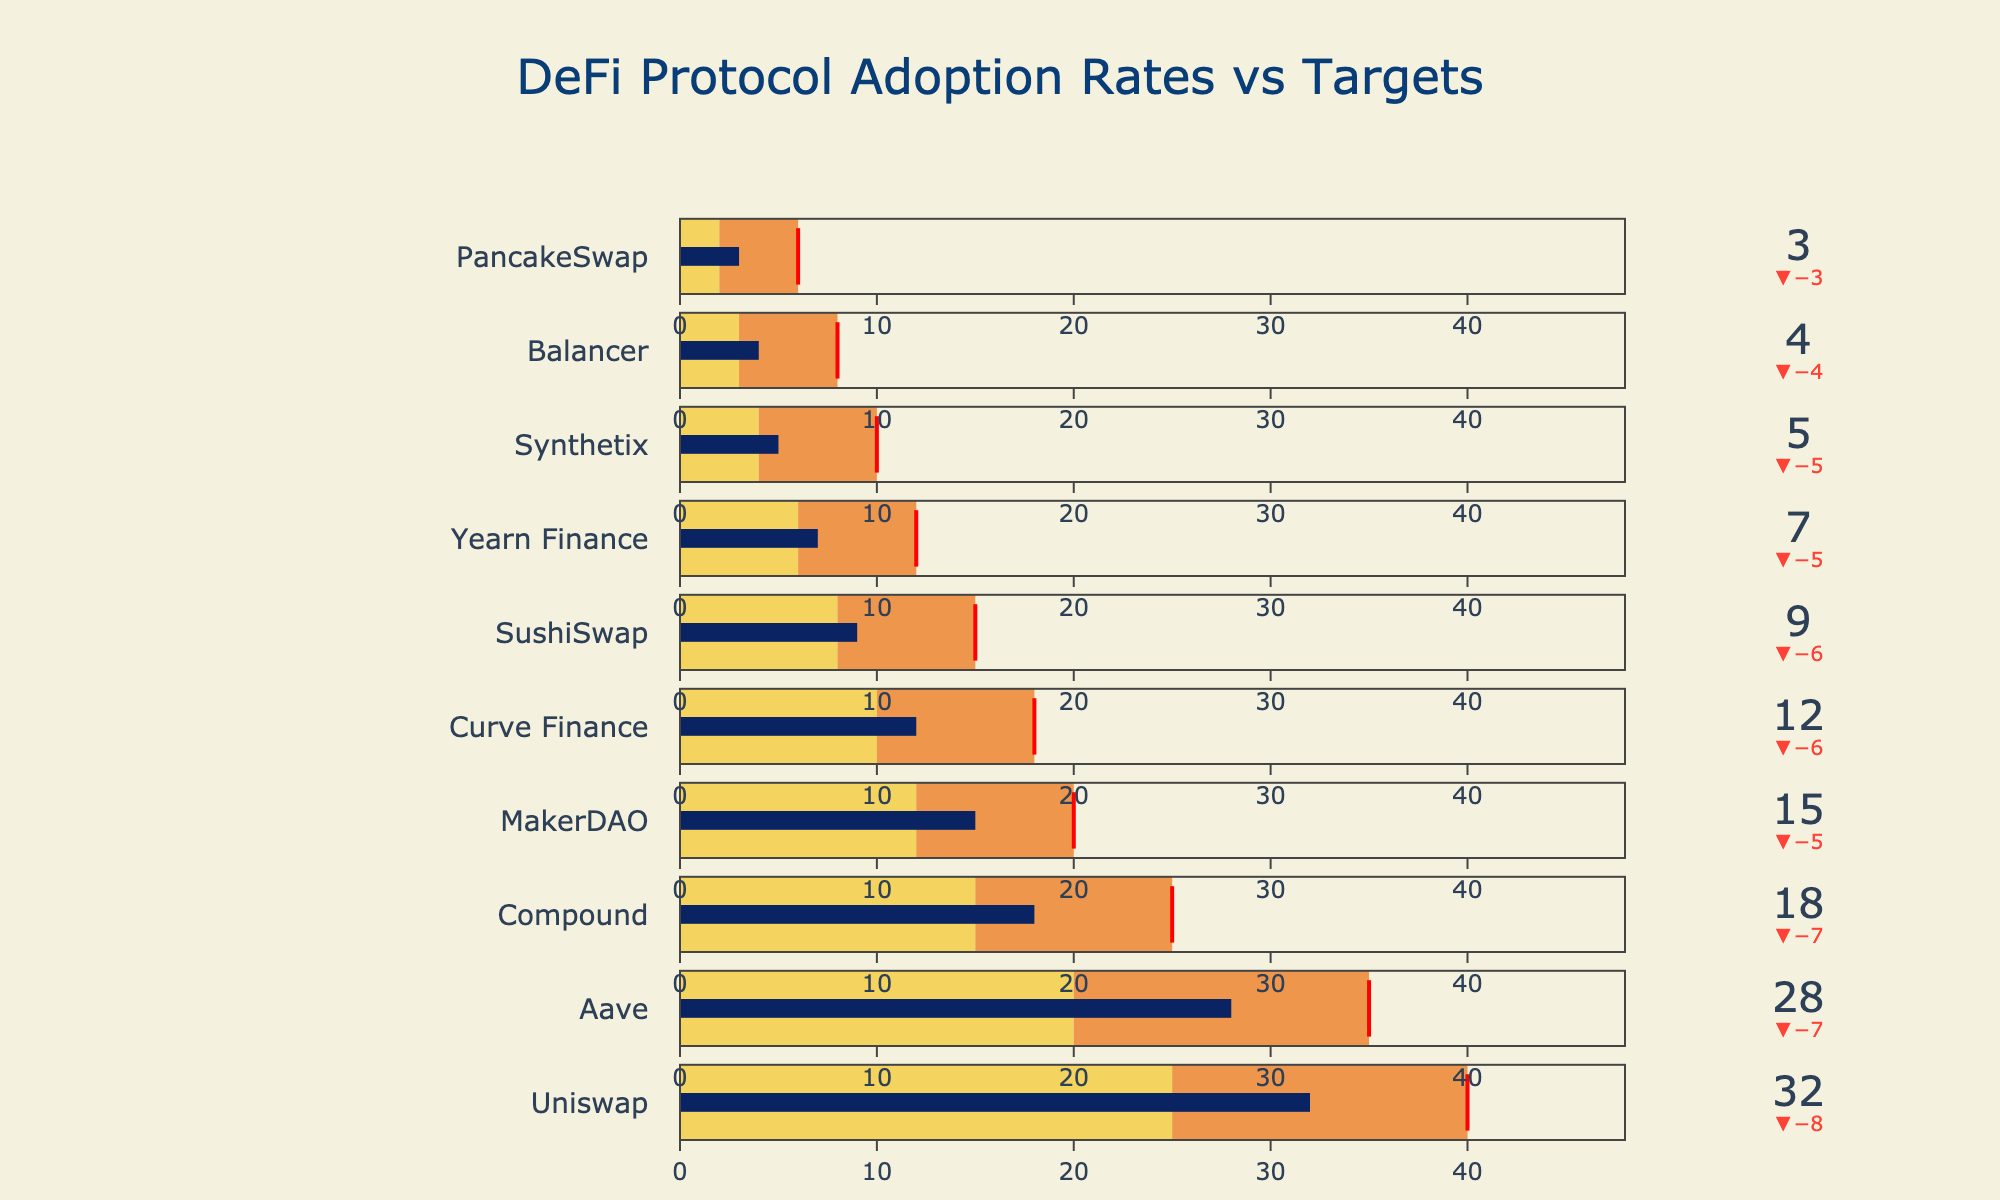What is the title of the figure? The title is typically displayed at the top of the figure, which provides an overview of what the figure represents.
Answer: DeFi Protocol Adoption Rates vs Targets What is the actual adoption rate of Uniswap? Locate the bullet chart corresponding to Uniswap and find the value indicated for actual adoption rate.
Answer: 32 Which protocol has the lowest adoption rate, and what is that rate? Compare the actual adoption rates for each protocol and identify the lowest value.
Answer: PancakeSwap, 3 What is the difference between the target and actual adoption rates for Aave? Subtract the actual adoption rate of Aave from its target adoption rate.
Answer: 7 Which protocols have exceeded their benchmarks but not their targets? Identify protocols where the actual adoption rate is higher than the benchmark but lower than the target.
Answer: Aave, Compound, MakerDAO, Curve Finance, Yearn Finance, Synthetix, Balancer, PancakeSwap How many protocols have an actual adoption rate greater than the benchmark for Synthetix? Identify the benchmark for Synthetix, then count how many protocols have an adoption rate exceeding that benchmark.
Answer: 7 What is the range of the axis for the bullet charts? The axis range for the bullet charts can be inferred from the maximum value, which is 1.2 times the highest target value. The highest target value is 40, so 40 * 1.2 = 48.
Answer: 0 to 48 Compare the actual adoption rates of Uniswap and Curve Finance. Which is higher, and by how much? Find the actual adoption rates for both Uniswap and Curve Finance, then calculate the difference.
Answer: Uniswap is higher by 20 Are there more protocols that have met or exceeded their targets or those that haven't? Count the number of protocols that have met or exceeded their targets and compare it to those that haven't.
Answer: More haven't met their targets 